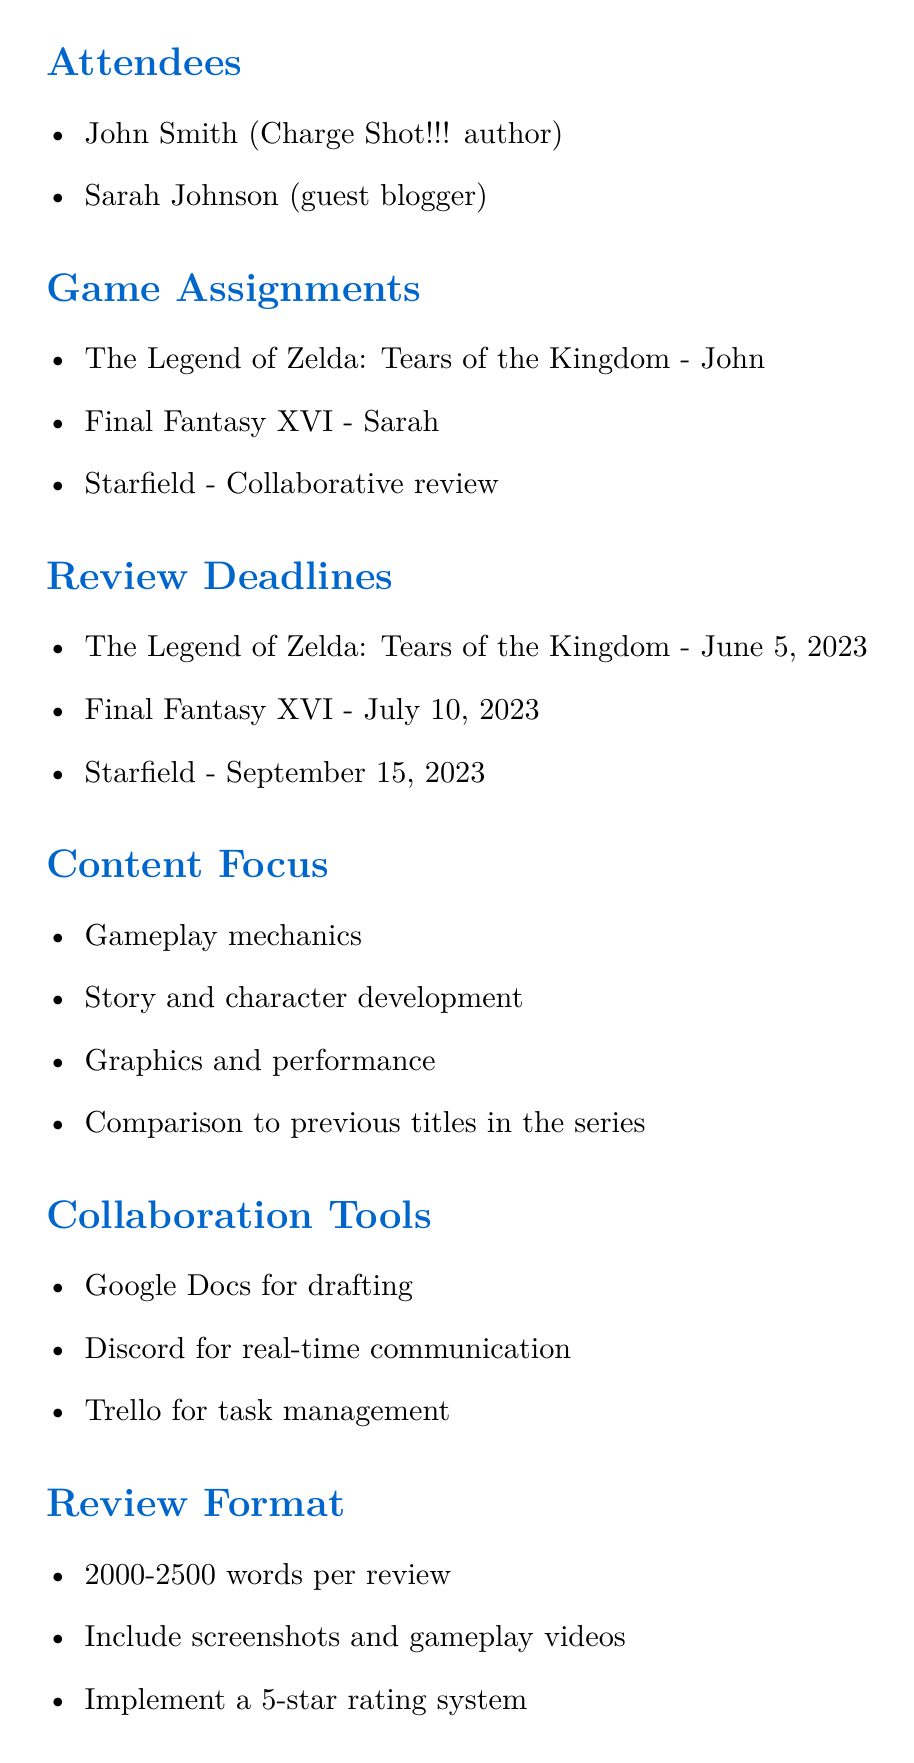What is the title of the meeting? The title of the meeting is explicitly stated at the beginning of the document.
Answer: Charge Shot!!! Collaborative Review Schedule Who is assigned to review Final Fantasy XVI? This is mentioned under the game assignments section of the document.
Answer: Sarah What is the deadline for The Legend of Zelda: Tears of the Kingdom review? The deadline is clearly listed in the review deadlines section.
Answer: June 5, 2023 Which game will be reviewed collaboratively? The document specifies which game will have a collaborative review under the game assignments section.
Answer: Starfield What content focus areas are included in the reviews? The content areas are outlined in the content focus section.
Answer: Gameplay mechanics, Story and character development, Graphics and performance, Comparison to previous titles in the series What tool will be used for real-time communication? The collaboration tools section lists the tools and their purposes.
Answer: Discord Who is responsible for scheduling weekly check-in calls? This action item is explicitly mentioned at the end of the document.
Answer: Both 